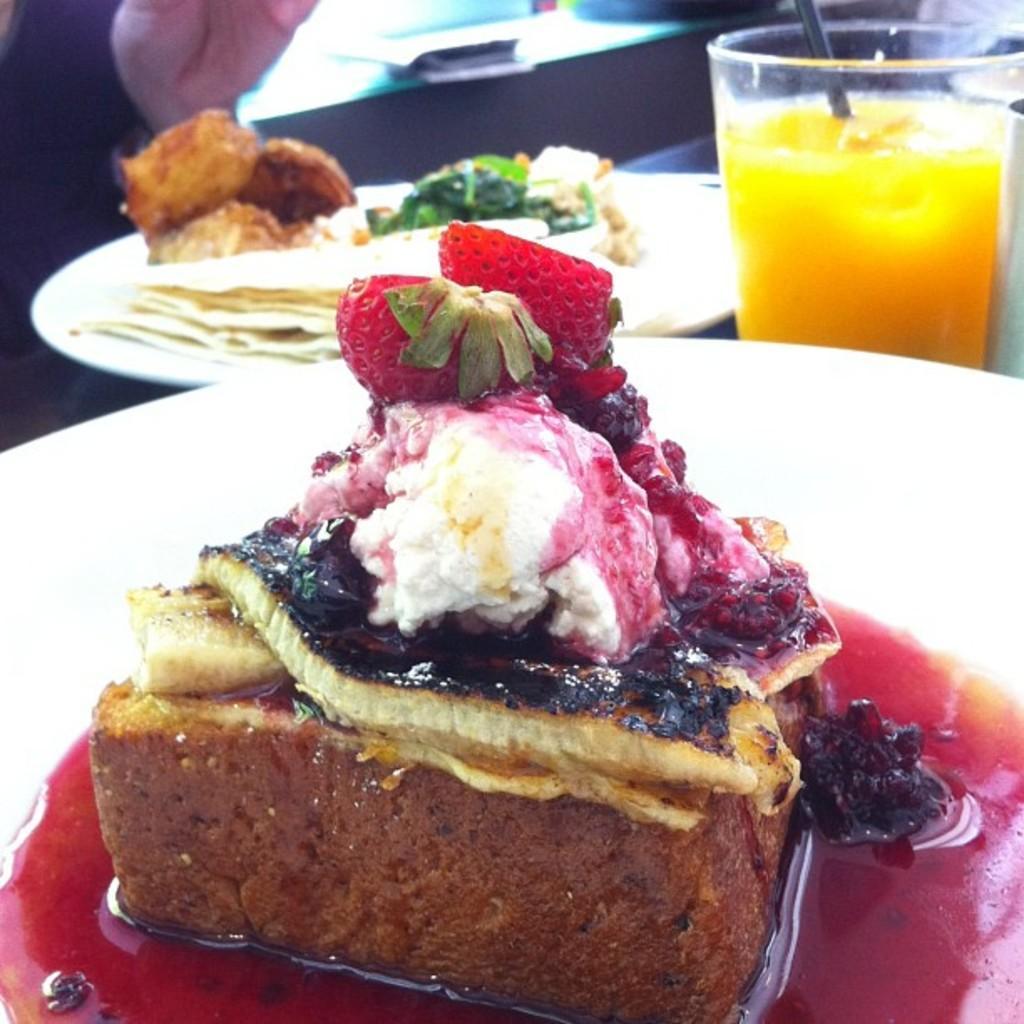In one or two sentences, can you explain what this image depicts? In this image we can see a cake, on the plate, there is a cream, and strawberries on it, beside, there is a plate and food item on it, there is a glass and some liquid in it. 